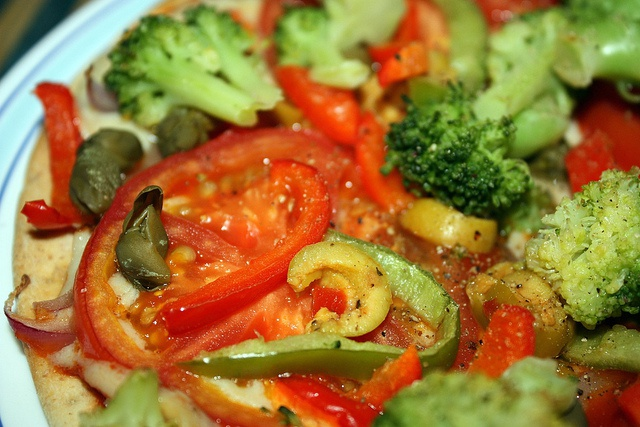Describe the objects in this image and their specific colors. I can see broccoli in black, olive, and khaki tones, broccoli in black, darkgreen, and olive tones, broccoli in black, lightgreen, olive, and darkgreen tones, broccoli in black and olive tones, and broccoli in black, lightgreen, khaki, and olive tones in this image. 